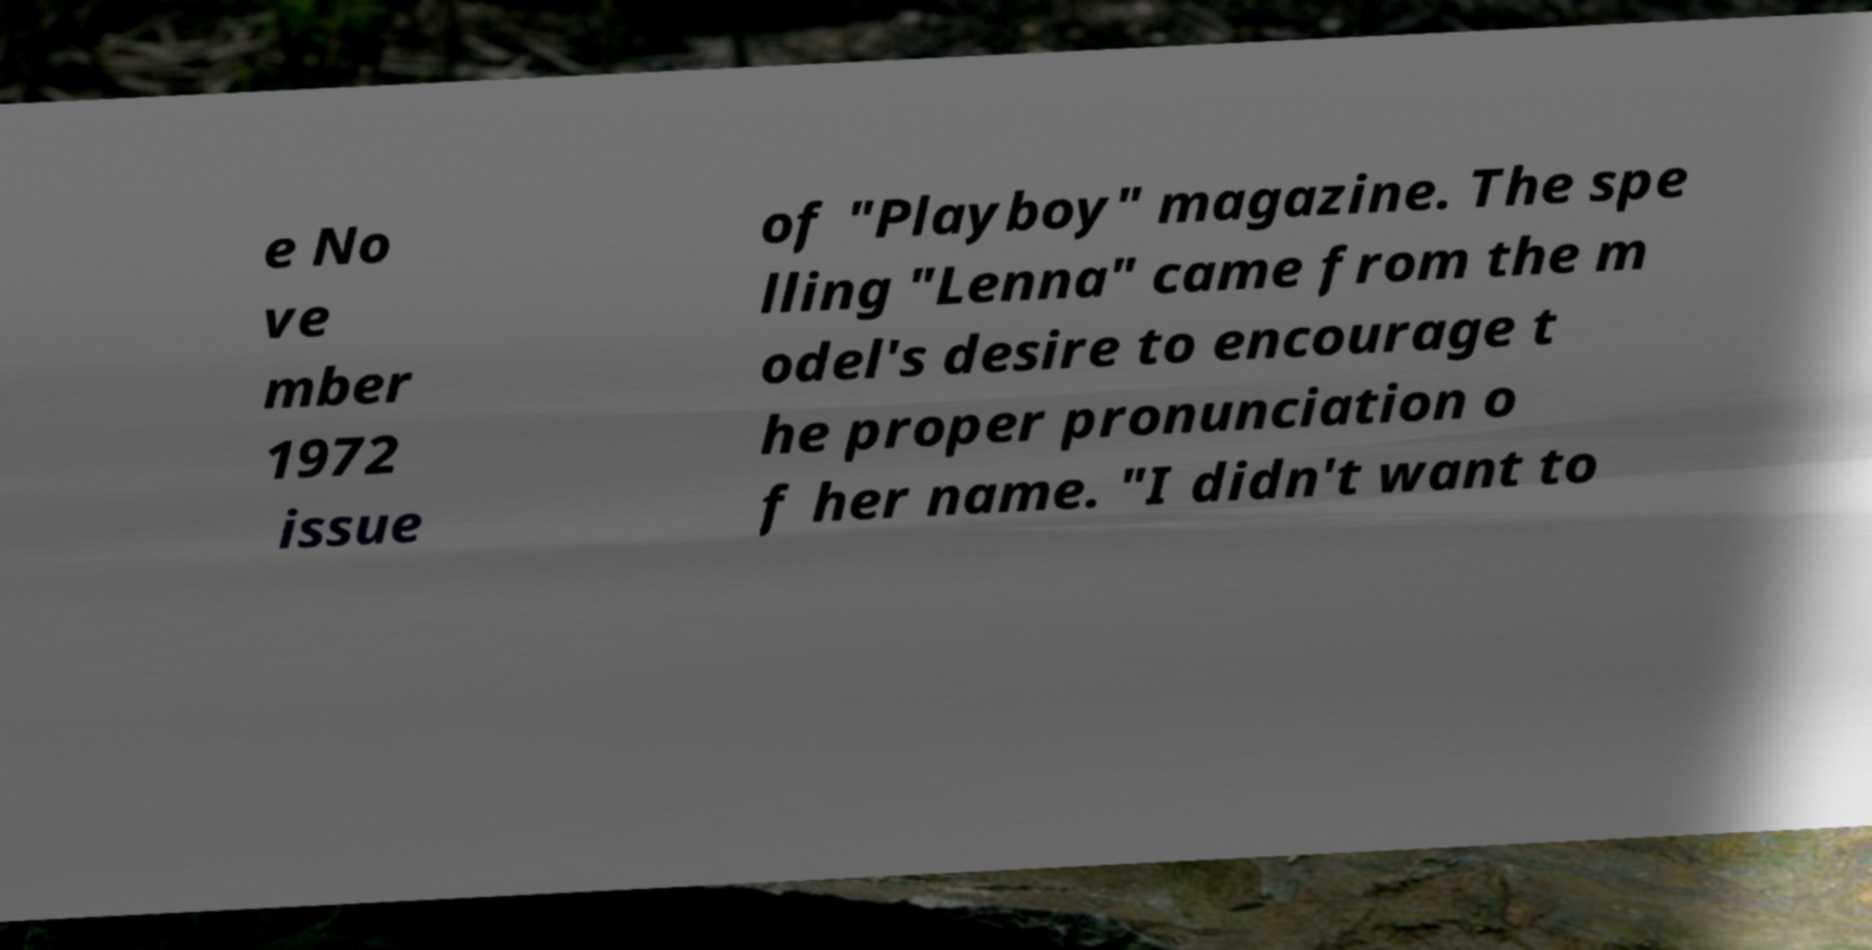Could you extract and type out the text from this image? e No ve mber 1972 issue of "Playboy" magazine. The spe lling "Lenna" came from the m odel's desire to encourage t he proper pronunciation o f her name. "I didn't want to 